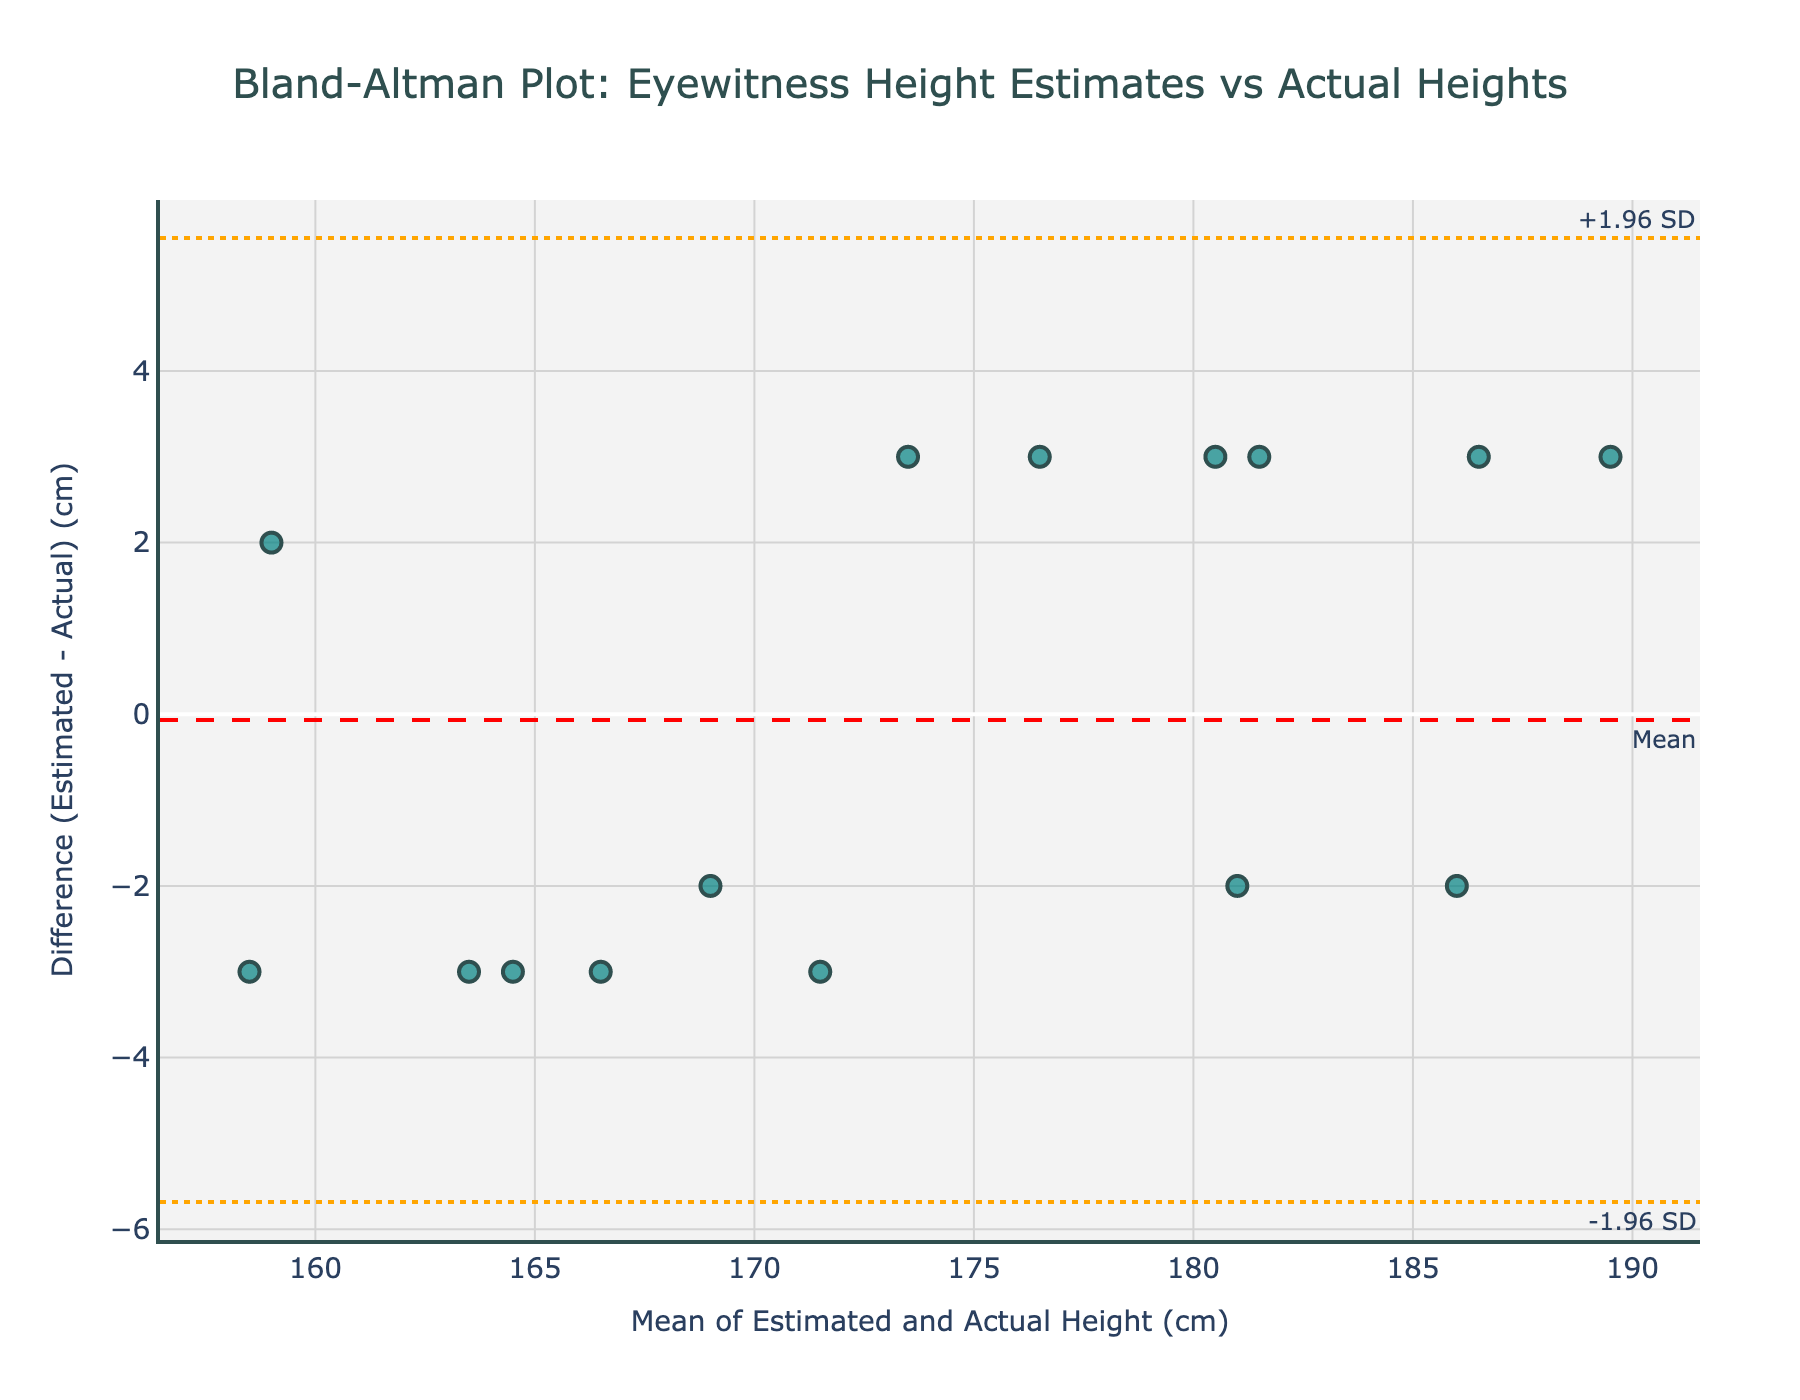How many data points are plotted in the figure? The figure shows data points that correspond to each suspect, and since there are 15 suspects listed in the data, there are 15 data points.
Answer: 15 What is the mean of the differences between the eyewitness estimates and actual heights? The mean is indicated by the red dashed line on the y-axis. By looking at the line, we can see that the mean difference is around 0.
Answer: Around 0 cm What are the limits of agreement displayed in the plot? The limits of agreement (LOA) are shown by the orange dotted lines on the y-axis. These lines represent +1.96 SD and -1.96 SD around the mean difference. By observing the figure, these limits are approximately +4 cm and -4 cm.
Answer: +4 cm and -4 cm Is there any data point where the difference exceeds the limits of agreement? To answer this, look for any points that lie outside the orange dotted lines. All data points are within the upper and lower limits of agreement.
Answer: No Which suspect's data point has the highest positive difference (Witness Estimate - Actual Height)? By examining the plot, we look for the uppermost point on the y-axis. The suspect with the highest positive difference is "Tyrone Johnson," with a difference of approximately 3 cm.
Answer: Tyrone Johnson Is there a trend suggesting systematic over- or underestimation of height by witnesses? Observing the spread of data points, they are dispersed fairly evenly around the mean line. This indicates no clear, systematic over- or underestimation trend.
Answer: No clear trend What does the Bland-Altman plot imply about the accuracy of eyewitness height estimates overall? The differences are mostly small and overall, points fall within the limits of agreement, showing that eyewitness estimates are generally close to actual heights, with some minor variations.
Answer: Close accuracy with minor variations 